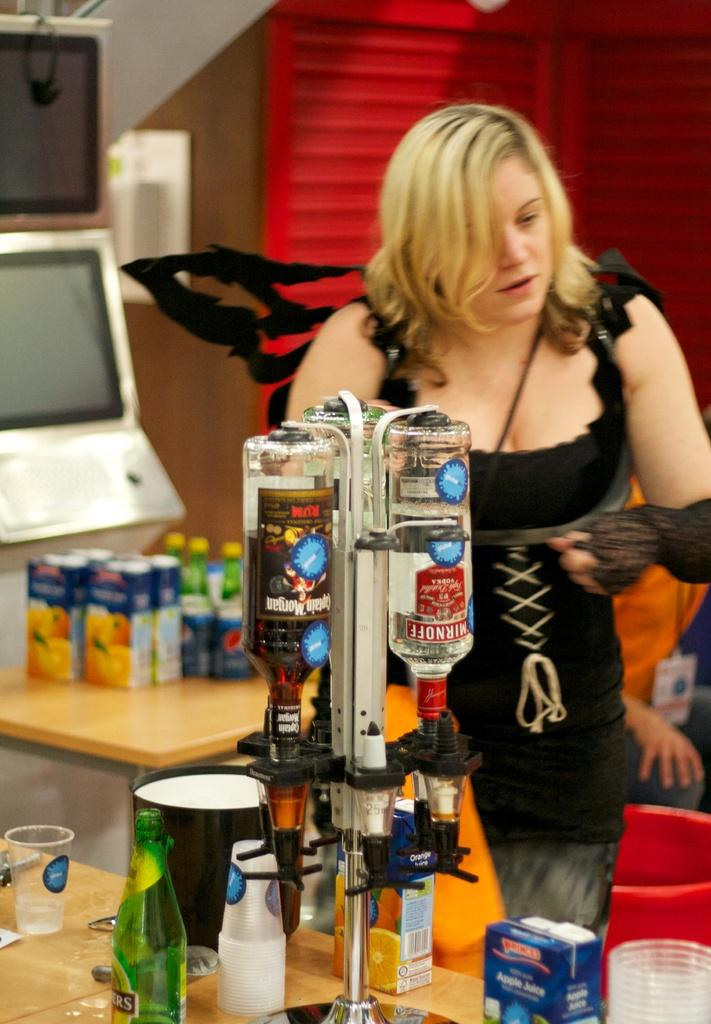What is the primary subject in the image? There is a woman standing in the image. What objects can be seen near the woman? There are bottles, glasses, boxes, tables, and a monitor visible in the image. Can you describe the person behind the woman? There is a person visible at the back of the woman. What type of structure is present in the image? There is a wall in the image. What type of pet can be seen interacting with the woman in the image? There is no pet present in the image; only the woman, objects, and the person behind her are visible. 